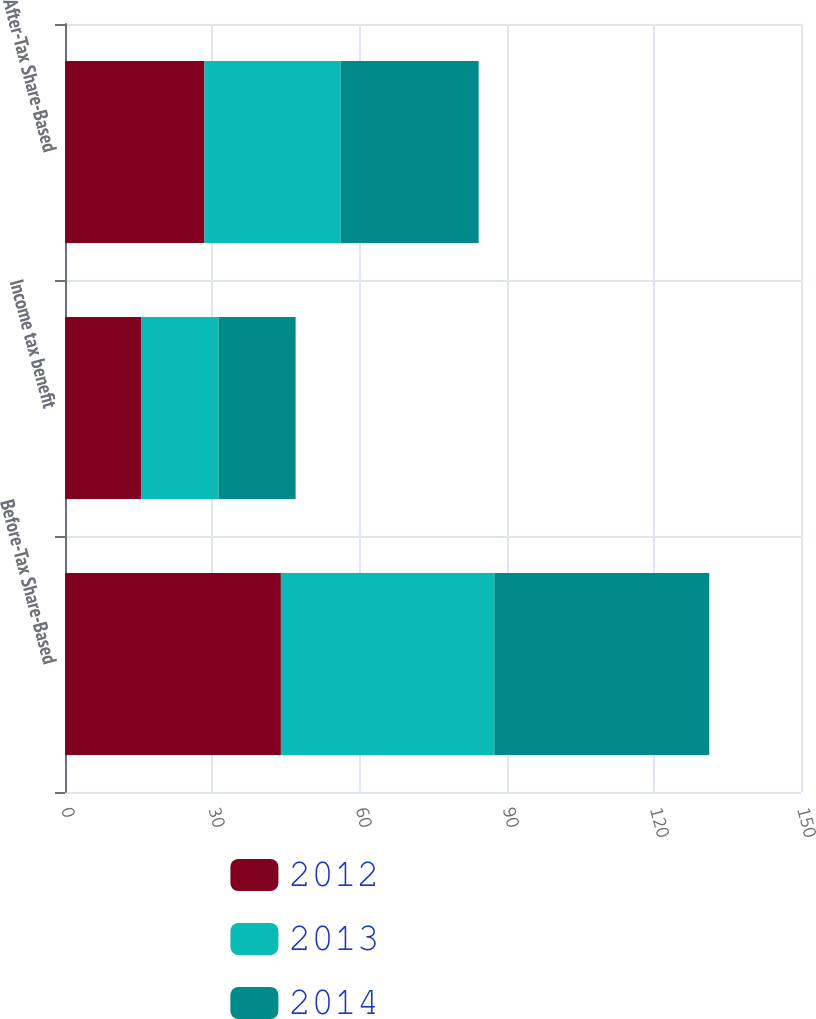Convert chart to OTSL. <chart><loc_0><loc_0><loc_500><loc_500><stacked_bar_chart><ecel><fcel>Before-Tax Share-Based<fcel>Income tax benefit<fcel>After-Tax Share-Based<nl><fcel>2012<fcel>44<fcel>15.6<fcel>28.4<nl><fcel>2013<fcel>43.5<fcel>15.7<fcel>27.8<nl><fcel>2014<fcel>43.8<fcel>15.7<fcel>28.1<nl></chart> 